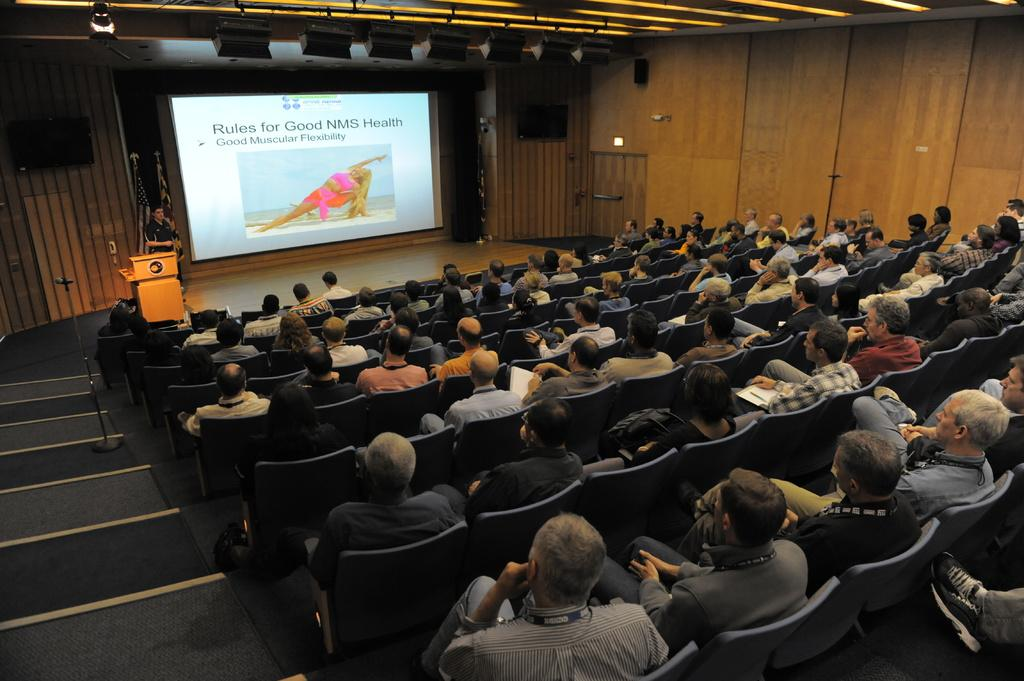Who or what is present in the image? There are people in the image. What are the people doing in the image? The people are sitting on chairs. What are the people looking at while sitting on the chairs? The people are looking at a big screen. What type of sail can be seen in the image? There is no sail present in the image; it features people sitting on chairs and looking at a big screen. How many kittens are sitting on the chairs with the people in the image? There are no kittens present in the image; it only features people sitting on chairs and looking at a big screen. 